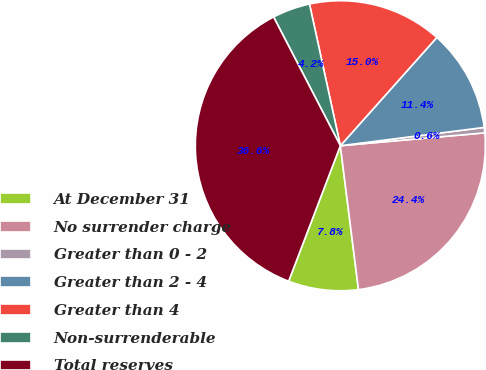<chart> <loc_0><loc_0><loc_500><loc_500><pie_chart><fcel>At December 31<fcel>No surrender charge<fcel>Greater than 0 - 2<fcel>Greater than 2 - 4<fcel>Greater than 4<fcel>Non-surrenderable<fcel>Total reserves<nl><fcel>7.8%<fcel>24.42%<fcel>0.6%<fcel>11.4%<fcel>15.0%<fcel>4.2%<fcel>36.59%<nl></chart> 